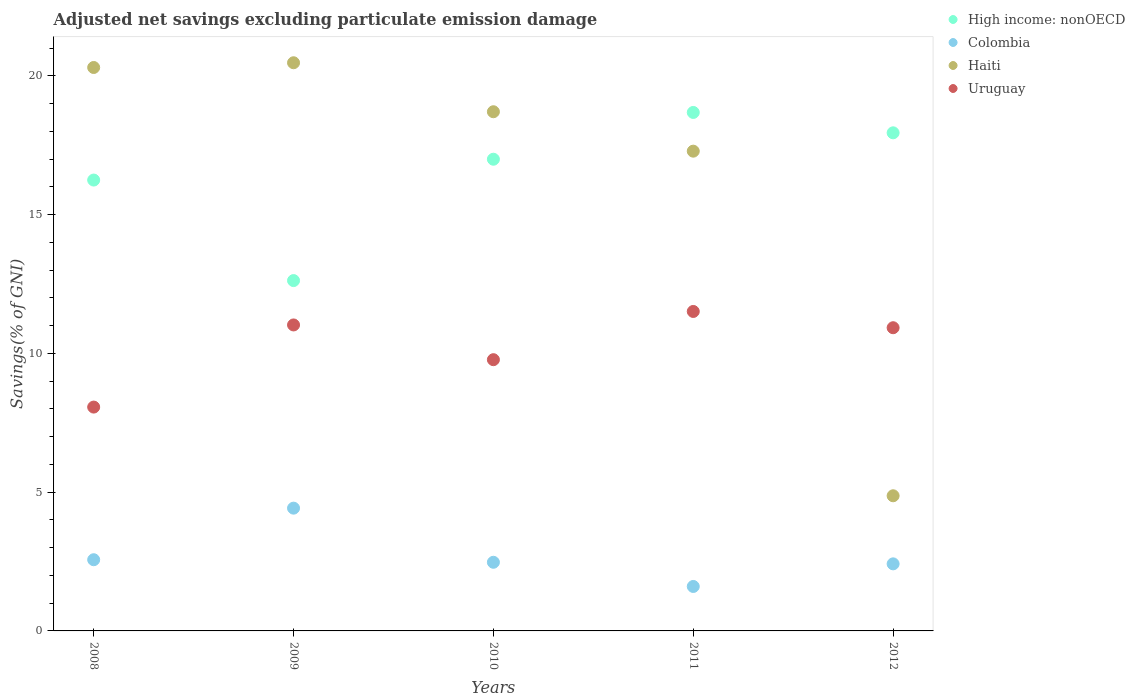Is the number of dotlines equal to the number of legend labels?
Your response must be concise. Yes. What is the adjusted net savings in Uruguay in 2009?
Your response must be concise. 11.03. Across all years, what is the maximum adjusted net savings in Uruguay?
Offer a very short reply. 11.51. Across all years, what is the minimum adjusted net savings in High income: nonOECD?
Provide a short and direct response. 12.62. In which year was the adjusted net savings in Colombia maximum?
Make the answer very short. 2009. What is the total adjusted net savings in Haiti in the graph?
Your answer should be compact. 81.64. What is the difference between the adjusted net savings in Colombia in 2009 and that in 2011?
Make the answer very short. 2.82. What is the difference between the adjusted net savings in Haiti in 2008 and the adjusted net savings in Colombia in 2009?
Provide a succinct answer. 15.88. What is the average adjusted net savings in Haiti per year?
Provide a short and direct response. 16.33. In the year 2012, what is the difference between the adjusted net savings in Haiti and adjusted net savings in Colombia?
Offer a terse response. 2.45. What is the ratio of the adjusted net savings in Colombia in 2011 to that in 2012?
Give a very brief answer. 0.66. Is the adjusted net savings in Colombia in 2009 less than that in 2010?
Ensure brevity in your answer.  No. What is the difference between the highest and the second highest adjusted net savings in Haiti?
Keep it short and to the point. 0.17. What is the difference between the highest and the lowest adjusted net savings in Uruguay?
Provide a short and direct response. 3.45. Is it the case that in every year, the sum of the adjusted net savings in Uruguay and adjusted net savings in Colombia  is greater than the adjusted net savings in High income: nonOECD?
Provide a short and direct response. No. Does the adjusted net savings in Colombia monotonically increase over the years?
Provide a succinct answer. No. Is the adjusted net savings in Uruguay strictly less than the adjusted net savings in High income: nonOECD over the years?
Provide a short and direct response. Yes. How many dotlines are there?
Your answer should be compact. 4. Are the values on the major ticks of Y-axis written in scientific E-notation?
Offer a very short reply. No. Does the graph contain any zero values?
Give a very brief answer. No. Does the graph contain grids?
Your answer should be very brief. No. What is the title of the graph?
Ensure brevity in your answer.  Adjusted net savings excluding particulate emission damage. Does "Ghana" appear as one of the legend labels in the graph?
Make the answer very short. No. What is the label or title of the X-axis?
Provide a short and direct response. Years. What is the label or title of the Y-axis?
Give a very brief answer. Savings(% of GNI). What is the Savings(% of GNI) of High income: nonOECD in 2008?
Provide a short and direct response. 16.25. What is the Savings(% of GNI) in Colombia in 2008?
Give a very brief answer. 2.57. What is the Savings(% of GNI) of Haiti in 2008?
Offer a terse response. 20.3. What is the Savings(% of GNI) in Uruguay in 2008?
Offer a terse response. 8.07. What is the Savings(% of GNI) in High income: nonOECD in 2009?
Offer a terse response. 12.62. What is the Savings(% of GNI) of Colombia in 2009?
Offer a terse response. 4.42. What is the Savings(% of GNI) of Haiti in 2009?
Provide a succinct answer. 20.47. What is the Savings(% of GNI) of Uruguay in 2009?
Offer a terse response. 11.03. What is the Savings(% of GNI) of High income: nonOECD in 2010?
Offer a terse response. 17. What is the Savings(% of GNI) in Colombia in 2010?
Offer a very short reply. 2.47. What is the Savings(% of GNI) of Haiti in 2010?
Give a very brief answer. 18.71. What is the Savings(% of GNI) in Uruguay in 2010?
Your response must be concise. 9.77. What is the Savings(% of GNI) of High income: nonOECD in 2011?
Your answer should be very brief. 18.68. What is the Savings(% of GNI) of Colombia in 2011?
Make the answer very short. 1.6. What is the Savings(% of GNI) in Haiti in 2011?
Give a very brief answer. 17.29. What is the Savings(% of GNI) in Uruguay in 2011?
Keep it short and to the point. 11.51. What is the Savings(% of GNI) in High income: nonOECD in 2012?
Offer a terse response. 17.95. What is the Savings(% of GNI) in Colombia in 2012?
Offer a very short reply. 2.42. What is the Savings(% of GNI) of Haiti in 2012?
Give a very brief answer. 4.87. What is the Savings(% of GNI) of Uruguay in 2012?
Your answer should be compact. 10.93. Across all years, what is the maximum Savings(% of GNI) in High income: nonOECD?
Make the answer very short. 18.68. Across all years, what is the maximum Savings(% of GNI) of Colombia?
Keep it short and to the point. 4.42. Across all years, what is the maximum Savings(% of GNI) of Haiti?
Provide a short and direct response. 20.47. Across all years, what is the maximum Savings(% of GNI) of Uruguay?
Offer a very short reply. 11.51. Across all years, what is the minimum Savings(% of GNI) of High income: nonOECD?
Provide a short and direct response. 12.62. Across all years, what is the minimum Savings(% of GNI) of Colombia?
Offer a terse response. 1.6. Across all years, what is the minimum Savings(% of GNI) of Haiti?
Your response must be concise. 4.87. Across all years, what is the minimum Savings(% of GNI) of Uruguay?
Make the answer very short. 8.07. What is the total Savings(% of GNI) of High income: nonOECD in the graph?
Your answer should be compact. 82.5. What is the total Savings(% of GNI) in Colombia in the graph?
Your answer should be compact. 13.48. What is the total Savings(% of GNI) of Haiti in the graph?
Ensure brevity in your answer.  81.64. What is the total Savings(% of GNI) in Uruguay in the graph?
Provide a succinct answer. 51.3. What is the difference between the Savings(% of GNI) of High income: nonOECD in 2008 and that in 2009?
Ensure brevity in your answer.  3.62. What is the difference between the Savings(% of GNI) in Colombia in 2008 and that in 2009?
Your answer should be very brief. -1.86. What is the difference between the Savings(% of GNI) of Haiti in 2008 and that in 2009?
Make the answer very short. -0.17. What is the difference between the Savings(% of GNI) of Uruguay in 2008 and that in 2009?
Make the answer very short. -2.96. What is the difference between the Savings(% of GNI) in High income: nonOECD in 2008 and that in 2010?
Keep it short and to the point. -0.75. What is the difference between the Savings(% of GNI) in Colombia in 2008 and that in 2010?
Ensure brevity in your answer.  0.09. What is the difference between the Savings(% of GNI) in Haiti in 2008 and that in 2010?
Ensure brevity in your answer.  1.59. What is the difference between the Savings(% of GNI) of Uruguay in 2008 and that in 2010?
Your answer should be compact. -1.71. What is the difference between the Savings(% of GNI) of High income: nonOECD in 2008 and that in 2011?
Keep it short and to the point. -2.44. What is the difference between the Savings(% of GNI) in Colombia in 2008 and that in 2011?
Keep it short and to the point. 0.96. What is the difference between the Savings(% of GNI) of Haiti in 2008 and that in 2011?
Offer a terse response. 3.02. What is the difference between the Savings(% of GNI) of Uruguay in 2008 and that in 2011?
Provide a succinct answer. -3.45. What is the difference between the Savings(% of GNI) in High income: nonOECD in 2008 and that in 2012?
Ensure brevity in your answer.  -1.7. What is the difference between the Savings(% of GNI) in Colombia in 2008 and that in 2012?
Provide a succinct answer. 0.15. What is the difference between the Savings(% of GNI) in Haiti in 2008 and that in 2012?
Make the answer very short. 15.43. What is the difference between the Savings(% of GNI) of Uruguay in 2008 and that in 2012?
Your response must be concise. -2.86. What is the difference between the Savings(% of GNI) in High income: nonOECD in 2009 and that in 2010?
Your answer should be compact. -4.37. What is the difference between the Savings(% of GNI) of Colombia in 2009 and that in 2010?
Your answer should be compact. 1.95. What is the difference between the Savings(% of GNI) in Haiti in 2009 and that in 2010?
Your answer should be compact. 1.77. What is the difference between the Savings(% of GNI) of Uruguay in 2009 and that in 2010?
Offer a very short reply. 1.25. What is the difference between the Savings(% of GNI) of High income: nonOECD in 2009 and that in 2011?
Provide a succinct answer. -6.06. What is the difference between the Savings(% of GNI) of Colombia in 2009 and that in 2011?
Offer a terse response. 2.82. What is the difference between the Savings(% of GNI) in Haiti in 2009 and that in 2011?
Provide a succinct answer. 3.19. What is the difference between the Savings(% of GNI) in Uruguay in 2009 and that in 2011?
Your answer should be very brief. -0.49. What is the difference between the Savings(% of GNI) of High income: nonOECD in 2009 and that in 2012?
Provide a short and direct response. -5.32. What is the difference between the Savings(% of GNI) of Colombia in 2009 and that in 2012?
Your answer should be compact. 2.01. What is the difference between the Savings(% of GNI) of Haiti in 2009 and that in 2012?
Provide a succinct answer. 15.6. What is the difference between the Savings(% of GNI) in Uruguay in 2009 and that in 2012?
Make the answer very short. 0.1. What is the difference between the Savings(% of GNI) in High income: nonOECD in 2010 and that in 2011?
Offer a very short reply. -1.69. What is the difference between the Savings(% of GNI) in Colombia in 2010 and that in 2011?
Your answer should be compact. 0.87. What is the difference between the Savings(% of GNI) of Haiti in 2010 and that in 2011?
Your answer should be very brief. 1.42. What is the difference between the Savings(% of GNI) in Uruguay in 2010 and that in 2011?
Give a very brief answer. -1.74. What is the difference between the Savings(% of GNI) of High income: nonOECD in 2010 and that in 2012?
Your answer should be very brief. -0.95. What is the difference between the Savings(% of GNI) of Colombia in 2010 and that in 2012?
Keep it short and to the point. 0.06. What is the difference between the Savings(% of GNI) in Haiti in 2010 and that in 2012?
Ensure brevity in your answer.  13.84. What is the difference between the Savings(% of GNI) in Uruguay in 2010 and that in 2012?
Keep it short and to the point. -1.15. What is the difference between the Savings(% of GNI) of High income: nonOECD in 2011 and that in 2012?
Provide a short and direct response. 0.73. What is the difference between the Savings(% of GNI) of Colombia in 2011 and that in 2012?
Make the answer very short. -0.81. What is the difference between the Savings(% of GNI) in Haiti in 2011 and that in 2012?
Give a very brief answer. 12.42. What is the difference between the Savings(% of GNI) of Uruguay in 2011 and that in 2012?
Provide a short and direct response. 0.59. What is the difference between the Savings(% of GNI) in High income: nonOECD in 2008 and the Savings(% of GNI) in Colombia in 2009?
Offer a terse response. 11.82. What is the difference between the Savings(% of GNI) in High income: nonOECD in 2008 and the Savings(% of GNI) in Haiti in 2009?
Provide a short and direct response. -4.23. What is the difference between the Savings(% of GNI) in High income: nonOECD in 2008 and the Savings(% of GNI) in Uruguay in 2009?
Keep it short and to the point. 5.22. What is the difference between the Savings(% of GNI) of Colombia in 2008 and the Savings(% of GNI) of Haiti in 2009?
Keep it short and to the point. -17.91. What is the difference between the Savings(% of GNI) in Colombia in 2008 and the Savings(% of GNI) in Uruguay in 2009?
Your answer should be very brief. -8.46. What is the difference between the Savings(% of GNI) in Haiti in 2008 and the Savings(% of GNI) in Uruguay in 2009?
Provide a succinct answer. 9.28. What is the difference between the Savings(% of GNI) in High income: nonOECD in 2008 and the Savings(% of GNI) in Colombia in 2010?
Your answer should be very brief. 13.77. What is the difference between the Savings(% of GNI) in High income: nonOECD in 2008 and the Savings(% of GNI) in Haiti in 2010?
Provide a short and direct response. -2.46. What is the difference between the Savings(% of GNI) of High income: nonOECD in 2008 and the Savings(% of GNI) of Uruguay in 2010?
Keep it short and to the point. 6.47. What is the difference between the Savings(% of GNI) in Colombia in 2008 and the Savings(% of GNI) in Haiti in 2010?
Your answer should be compact. -16.14. What is the difference between the Savings(% of GNI) in Colombia in 2008 and the Savings(% of GNI) in Uruguay in 2010?
Offer a very short reply. -7.21. What is the difference between the Savings(% of GNI) in Haiti in 2008 and the Savings(% of GNI) in Uruguay in 2010?
Your answer should be compact. 10.53. What is the difference between the Savings(% of GNI) of High income: nonOECD in 2008 and the Savings(% of GNI) of Colombia in 2011?
Provide a short and direct response. 14.64. What is the difference between the Savings(% of GNI) in High income: nonOECD in 2008 and the Savings(% of GNI) in Haiti in 2011?
Your answer should be very brief. -1.04. What is the difference between the Savings(% of GNI) of High income: nonOECD in 2008 and the Savings(% of GNI) of Uruguay in 2011?
Provide a short and direct response. 4.74. What is the difference between the Savings(% of GNI) of Colombia in 2008 and the Savings(% of GNI) of Haiti in 2011?
Your response must be concise. -14.72. What is the difference between the Savings(% of GNI) in Colombia in 2008 and the Savings(% of GNI) in Uruguay in 2011?
Your response must be concise. -8.95. What is the difference between the Savings(% of GNI) in Haiti in 2008 and the Savings(% of GNI) in Uruguay in 2011?
Offer a terse response. 8.79. What is the difference between the Savings(% of GNI) in High income: nonOECD in 2008 and the Savings(% of GNI) in Colombia in 2012?
Provide a succinct answer. 13.83. What is the difference between the Savings(% of GNI) in High income: nonOECD in 2008 and the Savings(% of GNI) in Haiti in 2012?
Your answer should be compact. 11.38. What is the difference between the Savings(% of GNI) of High income: nonOECD in 2008 and the Savings(% of GNI) of Uruguay in 2012?
Make the answer very short. 5.32. What is the difference between the Savings(% of GNI) in Colombia in 2008 and the Savings(% of GNI) in Haiti in 2012?
Your answer should be compact. -2.3. What is the difference between the Savings(% of GNI) in Colombia in 2008 and the Savings(% of GNI) in Uruguay in 2012?
Provide a short and direct response. -8.36. What is the difference between the Savings(% of GNI) of Haiti in 2008 and the Savings(% of GNI) of Uruguay in 2012?
Offer a terse response. 9.38. What is the difference between the Savings(% of GNI) in High income: nonOECD in 2009 and the Savings(% of GNI) in Colombia in 2010?
Your answer should be compact. 10.15. What is the difference between the Savings(% of GNI) in High income: nonOECD in 2009 and the Savings(% of GNI) in Haiti in 2010?
Provide a succinct answer. -6.08. What is the difference between the Savings(% of GNI) in High income: nonOECD in 2009 and the Savings(% of GNI) in Uruguay in 2010?
Make the answer very short. 2.85. What is the difference between the Savings(% of GNI) of Colombia in 2009 and the Savings(% of GNI) of Haiti in 2010?
Offer a very short reply. -14.28. What is the difference between the Savings(% of GNI) of Colombia in 2009 and the Savings(% of GNI) of Uruguay in 2010?
Offer a terse response. -5.35. What is the difference between the Savings(% of GNI) in Haiti in 2009 and the Savings(% of GNI) in Uruguay in 2010?
Provide a succinct answer. 10.7. What is the difference between the Savings(% of GNI) in High income: nonOECD in 2009 and the Savings(% of GNI) in Colombia in 2011?
Your answer should be very brief. 11.02. What is the difference between the Savings(% of GNI) in High income: nonOECD in 2009 and the Savings(% of GNI) in Haiti in 2011?
Ensure brevity in your answer.  -4.66. What is the difference between the Savings(% of GNI) of High income: nonOECD in 2009 and the Savings(% of GNI) of Uruguay in 2011?
Your response must be concise. 1.11. What is the difference between the Savings(% of GNI) in Colombia in 2009 and the Savings(% of GNI) in Haiti in 2011?
Your answer should be very brief. -12.86. What is the difference between the Savings(% of GNI) of Colombia in 2009 and the Savings(% of GNI) of Uruguay in 2011?
Offer a very short reply. -7.09. What is the difference between the Savings(% of GNI) of Haiti in 2009 and the Savings(% of GNI) of Uruguay in 2011?
Your answer should be compact. 8.96. What is the difference between the Savings(% of GNI) in High income: nonOECD in 2009 and the Savings(% of GNI) in Colombia in 2012?
Offer a terse response. 10.21. What is the difference between the Savings(% of GNI) in High income: nonOECD in 2009 and the Savings(% of GNI) in Haiti in 2012?
Your answer should be compact. 7.75. What is the difference between the Savings(% of GNI) of High income: nonOECD in 2009 and the Savings(% of GNI) of Uruguay in 2012?
Ensure brevity in your answer.  1.7. What is the difference between the Savings(% of GNI) in Colombia in 2009 and the Savings(% of GNI) in Haiti in 2012?
Make the answer very short. -0.45. What is the difference between the Savings(% of GNI) in Colombia in 2009 and the Savings(% of GNI) in Uruguay in 2012?
Provide a succinct answer. -6.5. What is the difference between the Savings(% of GNI) in Haiti in 2009 and the Savings(% of GNI) in Uruguay in 2012?
Your answer should be compact. 9.55. What is the difference between the Savings(% of GNI) in High income: nonOECD in 2010 and the Savings(% of GNI) in Colombia in 2011?
Your answer should be compact. 15.4. What is the difference between the Savings(% of GNI) in High income: nonOECD in 2010 and the Savings(% of GNI) in Haiti in 2011?
Provide a succinct answer. -0.29. What is the difference between the Savings(% of GNI) of High income: nonOECD in 2010 and the Savings(% of GNI) of Uruguay in 2011?
Provide a short and direct response. 5.49. What is the difference between the Savings(% of GNI) of Colombia in 2010 and the Savings(% of GNI) of Haiti in 2011?
Keep it short and to the point. -14.81. What is the difference between the Savings(% of GNI) of Colombia in 2010 and the Savings(% of GNI) of Uruguay in 2011?
Keep it short and to the point. -9.04. What is the difference between the Savings(% of GNI) in Haiti in 2010 and the Savings(% of GNI) in Uruguay in 2011?
Your answer should be compact. 7.2. What is the difference between the Savings(% of GNI) in High income: nonOECD in 2010 and the Savings(% of GNI) in Colombia in 2012?
Keep it short and to the point. 14.58. What is the difference between the Savings(% of GNI) in High income: nonOECD in 2010 and the Savings(% of GNI) in Haiti in 2012?
Keep it short and to the point. 12.13. What is the difference between the Savings(% of GNI) of High income: nonOECD in 2010 and the Savings(% of GNI) of Uruguay in 2012?
Give a very brief answer. 6.07. What is the difference between the Savings(% of GNI) in Colombia in 2010 and the Savings(% of GNI) in Haiti in 2012?
Ensure brevity in your answer.  -2.4. What is the difference between the Savings(% of GNI) in Colombia in 2010 and the Savings(% of GNI) in Uruguay in 2012?
Provide a succinct answer. -8.45. What is the difference between the Savings(% of GNI) of Haiti in 2010 and the Savings(% of GNI) of Uruguay in 2012?
Provide a succinct answer. 7.78. What is the difference between the Savings(% of GNI) in High income: nonOECD in 2011 and the Savings(% of GNI) in Colombia in 2012?
Provide a succinct answer. 16.27. What is the difference between the Savings(% of GNI) of High income: nonOECD in 2011 and the Savings(% of GNI) of Haiti in 2012?
Offer a very short reply. 13.81. What is the difference between the Savings(% of GNI) of High income: nonOECD in 2011 and the Savings(% of GNI) of Uruguay in 2012?
Ensure brevity in your answer.  7.76. What is the difference between the Savings(% of GNI) of Colombia in 2011 and the Savings(% of GNI) of Haiti in 2012?
Your answer should be very brief. -3.27. What is the difference between the Savings(% of GNI) of Colombia in 2011 and the Savings(% of GNI) of Uruguay in 2012?
Your answer should be compact. -9.32. What is the difference between the Savings(% of GNI) of Haiti in 2011 and the Savings(% of GNI) of Uruguay in 2012?
Keep it short and to the point. 6.36. What is the average Savings(% of GNI) of High income: nonOECD per year?
Provide a succinct answer. 16.5. What is the average Savings(% of GNI) in Colombia per year?
Your response must be concise. 2.7. What is the average Savings(% of GNI) of Haiti per year?
Your answer should be very brief. 16.33. What is the average Savings(% of GNI) in Uruguay per year?
Make the answer very short. 10.26. In the year 2008, what is the difference between the Savings(% of GNI) of High income: nonOECD and Savings(% of GNI) of Colombia?
Your answer should be very brief. 13.68. In the year 2008, what is the difference between the Savings(% of GNI) of High income: nonOECD and Savings(% of GNI) of Haiti?
Make the answer very short. -4.06. In the year 2008, what is the difference between the Savings(% of GNI) in High income: nonOECD and Savings(% of GNI) in Uruguay?
Keep it short and to the point. 8.18. In the year 2008, what is the difference between the Savings(% of GNI) of Colombia and Savings(% of GNI) of Haiti?
Provide a short and direct response. -17.74. In the year 2008, what is the difference between the Savings(% of GNI) of Colombia and Savings(% of GNI) of Uruguay?
Your answer should be compact. -5.5. In the year 2008, what is the difference between the Savings(% of GNI) of Haiti and Savings(% of GNI) of Uruguay?
Make the answer very short. 12.24. In the year 2009, what is the difference between the Savings(% of GNI) of High income: nonOECD and Savings(% of GNI) of Colombia?
Offer a very short reply. 8.2. In the year 2009, what is the difference between the Savings(% of GNI) of High income: nonOECD and Savings(% of GNI) of Haiti?
Make the answer very short. -7.85. In the year 2009, what is the difference between the Savings(% of GNI) of High income: nonOECD and Savings(% of GNI) of Uruguay?
Offer a very short reply. 1.6. In the year 2009, what is the difference between the Savings(% of GNI) of Colombia and Savings(% of GNI) of Haiti?
Keep it short and to the point. -16.05. In the year 2009, what is the difference between the Savings(% of GNI) of Colombia and Savings(% of GNI) of Uruguay?
Ensure brevity in your answer.  -6.6. In the year 2009, what is the difference between the Savings(% of GNI) in Haiti and Savings(% of GNI) in Uruguay?
Provide a short and direct response. 9.45. In the year 2010, what is the difference between the Savings(% of GNI) of High income: nonOECD and Savings(% of GNI) of Colombia?
Your answer should be compact. 14.52. In the year 2010, what is the difference between the Savings(% of GNI) of High income: nonOECD and Savings(% of GNI) of Haiti?
Your answer should be very brief. -1.71. In the year 2010, what is the difference between the Savings(% of GNI) in High income: nonOECD and Savings(% of GNI) in Uruguay?
Your response must be concise. 7.22. In the year 2010, what is the difference between the Savings(% of GNI) of Colombia and Savings(% of GNI) of Haiti?
Your answer should be very brief. -16.23. In the year 2010, what is the difference between the Savings(% of GNI) of Colombia and Savings(% of GNI) of Uruguay?
Offer a terse response. -7.3. In the year 2010, what is the difference between the Savings(% of GNI) in Haiti and Savings(% of GNI) in Uruguay?
Give a very brief answer. 8.93. In the year 2011, what is the difference between the Savings(% of GNI) of High income: nonOECD and Savings(% of GNI) of Colombia?
Keep it short and to the point. 17.08. In the year 2011, what is the difference between the Savings(% of GNI) in High income: nonOECD and Savings(% of GNI) in Haiti?
Give a very brief answer. 1.4. In the year 2011, what is the difference between the Savings(% of GNI) in High income: nonOECD and Savings(% of GNI) in Uruguay?
Your response must be concise. 7.17. In the year 2011, what is the difference between the Savings(% of GNI) of Colombia and Savings(% of GNI) of Haiti?
Your answer should be compact. -15.69. In the year 2011, what is the difference between the Savings(% of GNI) of Colombia and Savings(% of GNI) of Uruguay?
Offer a terse response. -9.91. In the year 2011, what is the difference between the Savings(% of GNI) in Haiti and Savings(% of GNI) in Uruguay?
Give a very brief answer. 5.78. In the year 2012, what is the difference between the Savings(% of GNI) in High income: nonOECD and Savings(% of GNI) in Colombia?
Your answer should be very brief. 15.53. In the year 2012, what is the difference between the Savings(% of GNI) in High income: nonOECD and Savings(% of GNI) in Haiti?
Keep it short and to the point. 13.08. In the year 2012, what is the difference between the Savings(% of GNI) in High income: nonOECD and Savings(% of GNI) in Uruguay?
Make the answer very short. 7.02. In the year 2012, what is the difference between the Savings(% of GNI) in Colombia and Savings(% of GNI) in Haiti?
Make the answer very short. -2.45. In the year 2012, what is the difference between the Savings(% of GNI) of Colombia and Savings(% of GNI) of Uruguay?
Offer a terse response. -8.51. In the year 2012, what is the difference between the Savings(% of GNI) of Haiti and Savings(% of GNI) of Uruguay?
Provide a short and direct response. -6.06. What is the ratio of the Savings(% of GNI) in High income: nonOECD in 2008 to that in 2009?
Your response must be concise. 1.29. What is the ratio of the Savings(% of GNI) of Colombia in 2008 to that in 2009?
Ensure brevity in your answer.  0.58. What is the ratio of the Savings(% of GNI) in Haiti in 2008 to that in 2009?
Offer a very short reply. 0.99. What is the ratio of the Savings(% of GNI) in Uruguay in 2008 to that in 2009?
Your answer should be compact. 0.73. What is the ratio of the Savings(% of GNI) in High income: nonOECD in 2008 to that in 2010?
Your response must be concise. 0.96. What is the ratio of the Savings(% of GNI) of Colombia in 2008 to that in 2010?
Your answer should be very brief. 1.04. What is the ratio of the Savings(% of GNI) of Haiti in 2008 to that in 2010?
Your answer should be very brief. 1.09. What is the ratio of the Savings(% of GNI) in Uruguay in 2008 to that in 2010?
Offer a terse response. 0.83. What is the ratio of the Savings(% of GNI) of High income: nonOECD in 2008 to that in 2011?
Offer a terse response. 0.87. What is the ratio of the Savings(% of GNI) of Colombia in 2008 to that in 2011?
Offer a very short reply. 1.6. What is the ratio of the Savings(% of GNI) in Haiti in 2008 to that in 2011?
Your answer should be compact. 1.17. What is the ratio of the Savings(% of GNI) in Uruguay in 2008 to that in 2011?
Provide a short and direct response. 0.7. What is the ratio of the Savings(% of GNI) in High income: nonOECD in 2008 to that in 2012?
Give a very brief answer. 0.91. What is the ratio of the Savings(% of GNI) in Colombia in 2008 to that in 2012?
Offer a very short reply. 1.06. What is the ratio of the Savings(% of GNI) of Haiti in 2008 to that in 2012?
Make the answer very short. 4.17. What is the ratio of the Savings(% of GNI) in Uruguay in 2008 to that in 2012?
Offer a terse response. 0.74. What is the ratio of the Savings(% of GNI) in High income: nonOECD in 2009 to that in 2010?
Your answer should be very brief. 0.74. What is the ratio of the Savings(% of GNI) of Colombia in 2009 to that in 2010?
Provide a short and direct response. 1.79. What is the ratio of the Savings(% of GNI) in Haiti in 2009 to that in 2010?
Make the answer very short. 1.09. What is the ratio of the Savings(% of GNI) in Uruguay in 2009 to that in 2010?
Offer a very short reply. 1.13. What is the ratio of the Savings(% of GNI) in High income: nonOECD in 2009 to that in 2011?
Offer a terse response. 0.68. What is the ratio of the Savings(% of GNI) in Colombia in 2009 to that in 2011?
Your answer should be very brief. 2.76. What is the ratio of the Savings(% of GNI) in Haiti in 2009 to that in 2011?
Provide a short and direct response. 1.18. What is the ratio of the Savings(% of GNI) in Uruguay in 2009 to that in 2011?
Your answer should be very brief. 0.96. What is the ratio of the Savings(% of GNI) in High income: nonOECD in 2009 to that in 2012?
Keep it short and to the point. 0.7. What is the ratio of the Savings(% of GNI) of Colombia in 2009 to that in 2012?
Provide a short and direct response. 1.83. What is the ratio of the Savings(% of GNI) of Haiti in 2009 to that in 2012?
Provide a short and direct response. 4.2. What is the ratio of the Savings(% of GNI) in Uruguay in 2009 to that in 2012?
Provide a short and direct response. 1.01. What is the ratio of the Savings(% of GNI) of High income: nonOECD in 2010 to that in 2011?
Offer a terse response. 0.91. What is the ratio of the Savings(% of GNI) of Colombia in 2010 to that in 2011?
Offer a very short reply. 1.54. What is the ratio of the Savings(% of GNI) in Haiti in 2010 to that in 2011?
Offer a very short reply. 1.08. What is the ratio of the Savings(% of GNI) in Uruguay in 2010 to that in 2011?
Provide a succinct answer. 0.85. What is the ratio of the Savings(% of GNI) of High income: nonOECD in 2010 to that in 2012?
Provide a succinct answer. 0.95. What is the ratio of the Savings(% of GNI) of Colombia in 2010 to that in 2012?
Offer a terse response. 1.02. What is the ratio of the Savings(% of GNI) in Haiti in 2010 to that in 2012?
Make the answer very short. 3.84. What is the ratio of the Savings(% of GNI) in Uruguay in 2010 to that in 2012?
Your answer should be compact. 0.89. What is the ratio of the Savings(% of GNI) of High income: nonOECD in 2011 to that in 2012?
Offer a very short reply. 1.04. What is the ratio of the Savings(% of GNI) in Colombia in 2011 to that in 2012?
Make the answer very short. 0.66. What is the ratio of the Savings(% of GNI) in Haiti in 2011 to that in 2012?
Your response must be concise. 3.55. What is the ratio of the Savings(% of GNI) in Uruguay in 2011 to that in 2012?
Your answer should be compact. 1.05. What is the difference between the highest and the second highest Savings(% of GNI) of High income: nonOECD?
Your response must be concise. 0.73. What is the difference between the highest and the second highest Savings(% of GNI) of Colombia?
Make the answer very short. 1.86. What is the difference between the highest and the second highest Savings(% of GNI) of Haiti?
Provide a succinct answer. 0.17. What is the difference between the highest and the second highest Savings(% of GNI) of Uruguay?
Provide a succinct answer. 0.49. What is the difference between the highest and the lowest Savings(% of GNI) in High income: nonOECD?
Provide a short and direct response. 6.06. What is the difference between the highest and the lowest Savings(% of GNI) in Colombia?
Offer a very short reply. 2.82. What is the difference between the highest and the lowest Savings(% of GNI) of Haiti?
Offer a terse response. 15.6. What is the difference between the highest and the lowest Savings(% of GNI) of Uruguay?
Provide a succinct answer. 3.45. 